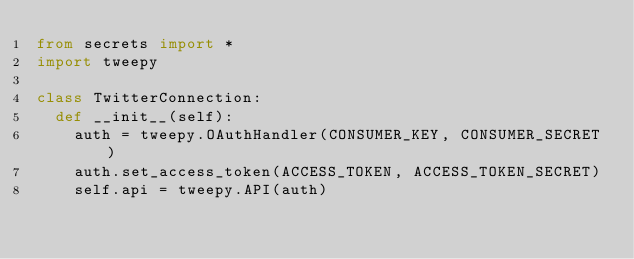Convert code to text. <code><loc_0><loc_0><loc_500><loc_500><_Python_>from secrets import *
import tweepy

class TwitterConnection:
  def __init__(self):
    auth = tweepy.OAuthHandler(CONSUMER_KEY, CONSUMER_SECRET)
    auth.set_access_token(ACCESS_TOKEN, ACCESS_TOKEN_SECRET)
    self.api = tweepy.API(auth)
</code> 